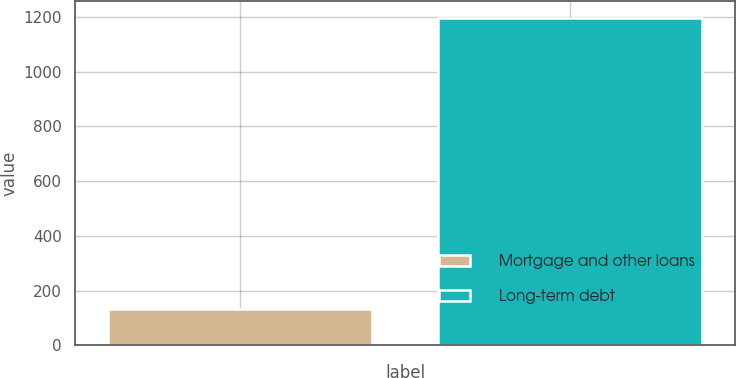Convert chart to OTSL. <chart><loc_0><loc_0><loc_500><loc_500><bar_chart><fcel>Mortgage and other loans<fcel>Long-term debt<nl><fcel>134<fcel>1197<nl></chart> 